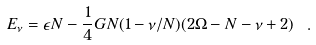Convert formula to latex. <formula><loc_0><loc_0><loc_500><loc_500>E _ { \nu } = \epsilon N - \frac { 1 } { 4 } G N ( 1 - \nu / N ) ( 2 \Omega - N - \nu + 2 ) \ .</formula> 